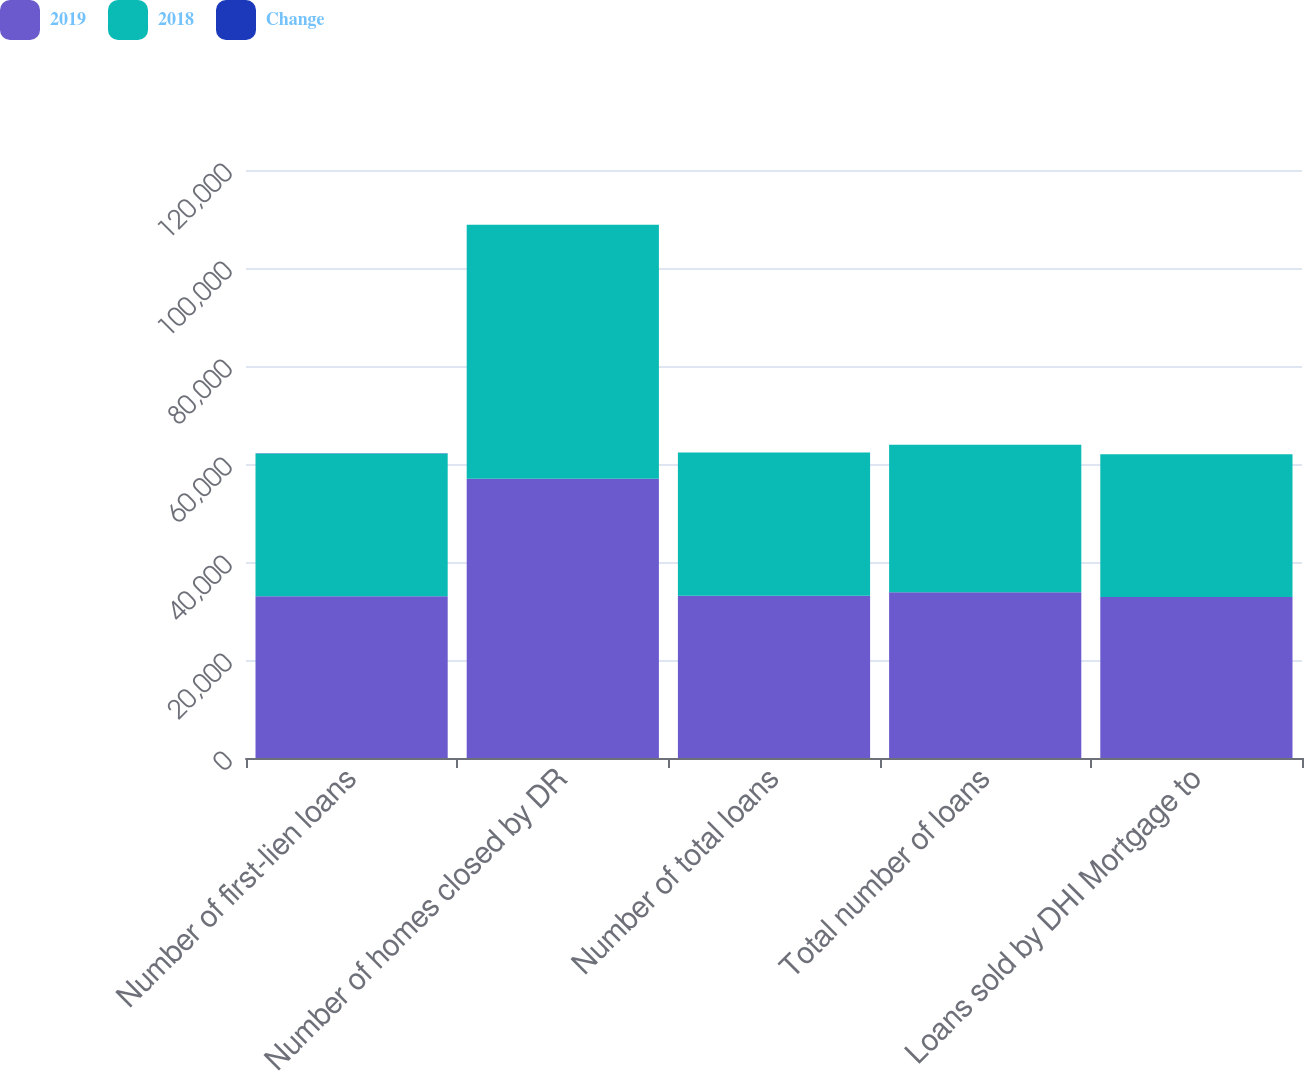Convert chart. <chart><loc_0><loc_0><loc_500><loc_500><stacked_bar_chart><ecel><fcel>Number of first-lien loans<fcel>Number of homes closed by DR<fcel>Number of total loans<fcel>Total number of loans<fcel>Loans sold by DHI Mortgage to<nl><fcel>2019<fcel>33024<fcel>56975<fcel>33114<fcel>33827<fcel>32849<nl><fcel>2018<fcel>29133<fcel>51857<fcel>29234<fcel>30107<fcel>29120<nl><fcel>Change<fcel>13<fcel>10<fcel>13<fcel>12<fcel>13<nl></chart> 